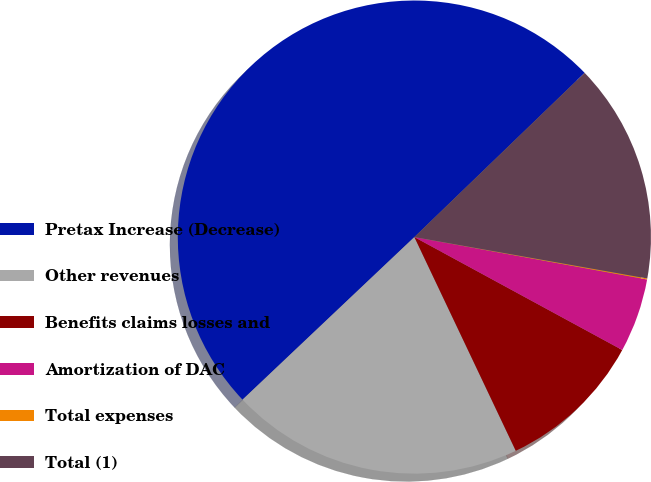Convert chart. <chart><loc_0><loc_0><loc_500><loc_500><pie_chart><fcel>Pretax Increase (Decrease)<fcel>Other revenues<fcel>Benefits claims losses and<fcel>Amortization of DAC<fcel>Total expenses<fcel>Total (1)<nl><fcel>49.85%<fcel>19.99%<fcel>10.03%<fcel>5.05%<fcel>0.07%<fcel>15.01%<nl></chart> 